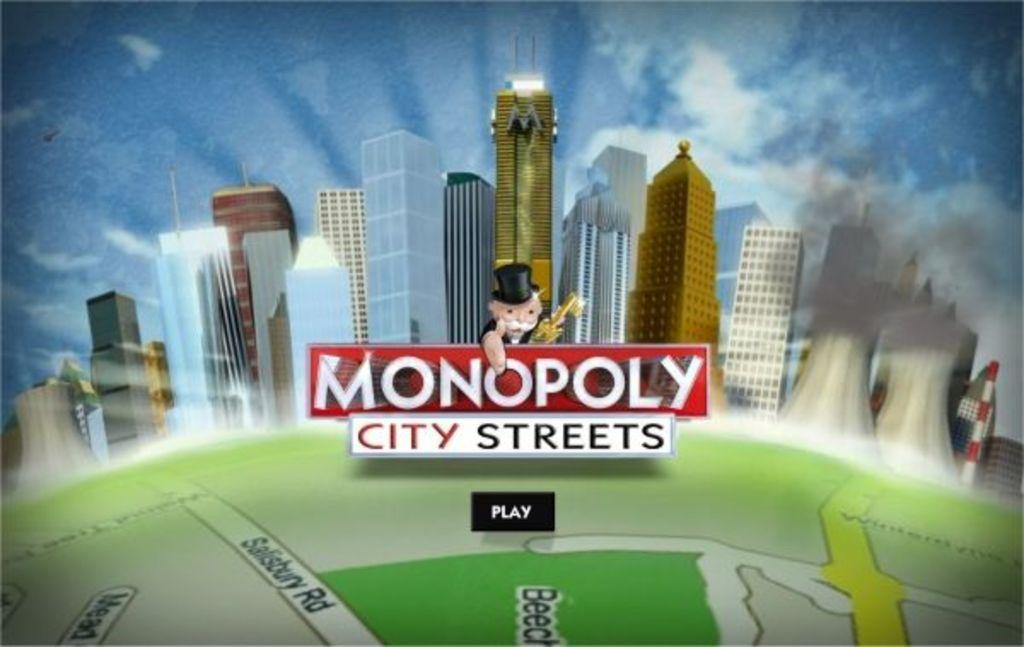<image>
Write a terse but informative summary of the picture. a screen shot for Monopoloy City Streets on the Play screen 